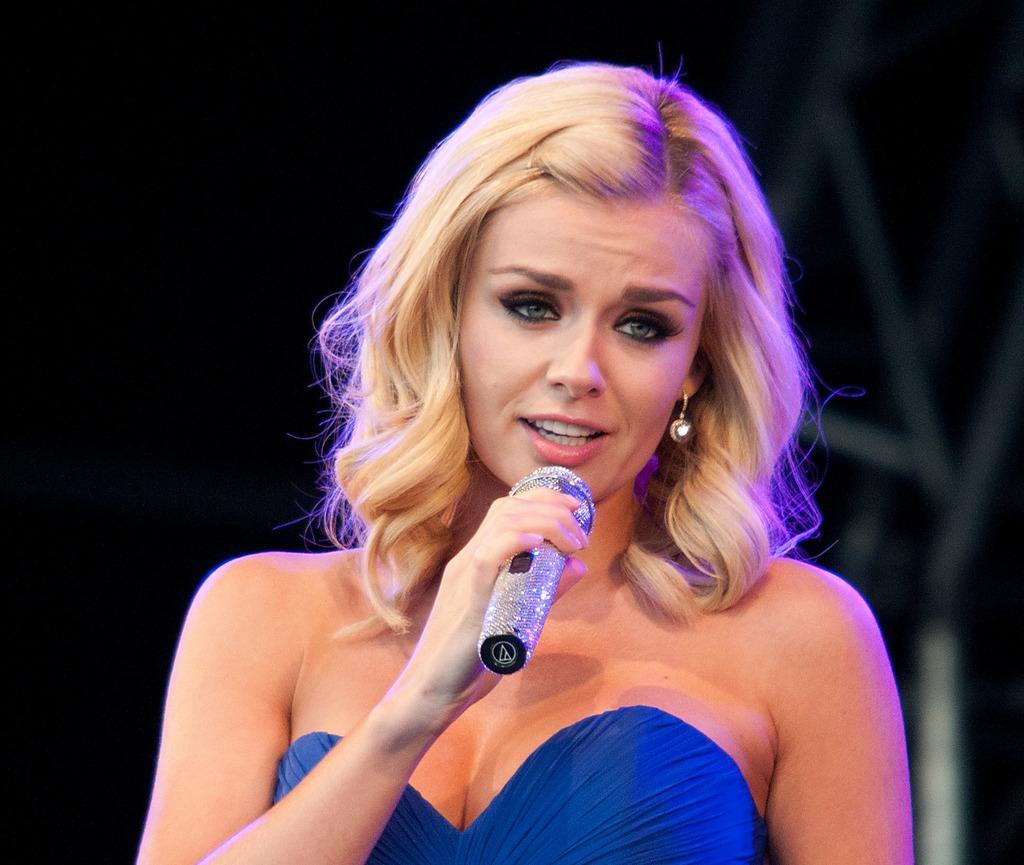In one or two sentences, can you explain what this image depicts? In this picture a woman is talking with the help of microphone. 